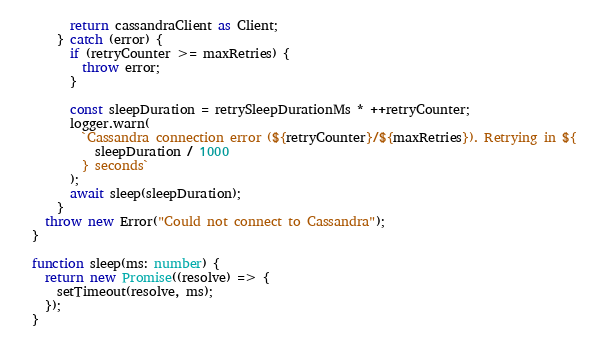Convert code to text. <code><loc_0><loc_0><loc_500><loc_500><_TypeScript_>      return cassandraClient as Client;
    } catch (error) {
      if (retryCounter >= maxRetries) {
        throw error;
      }

      const sleepDuration = retrySleepDurationMs * ++retryCounter;
      logger.warn(
        `Cassandra connection error (${retryCounter}/${maxRetries}). Retrying in ${
          sleepDuration / 1000
        } seconds`
      );
      await sleep(sleepDuration);
    }
  throw new Error("Could not connect to Cassandra");
}

function sleep(ms: number) {
  return new Promise((resolve) => {
    setTimeout(resolve, ms);
  });
}
</code> 